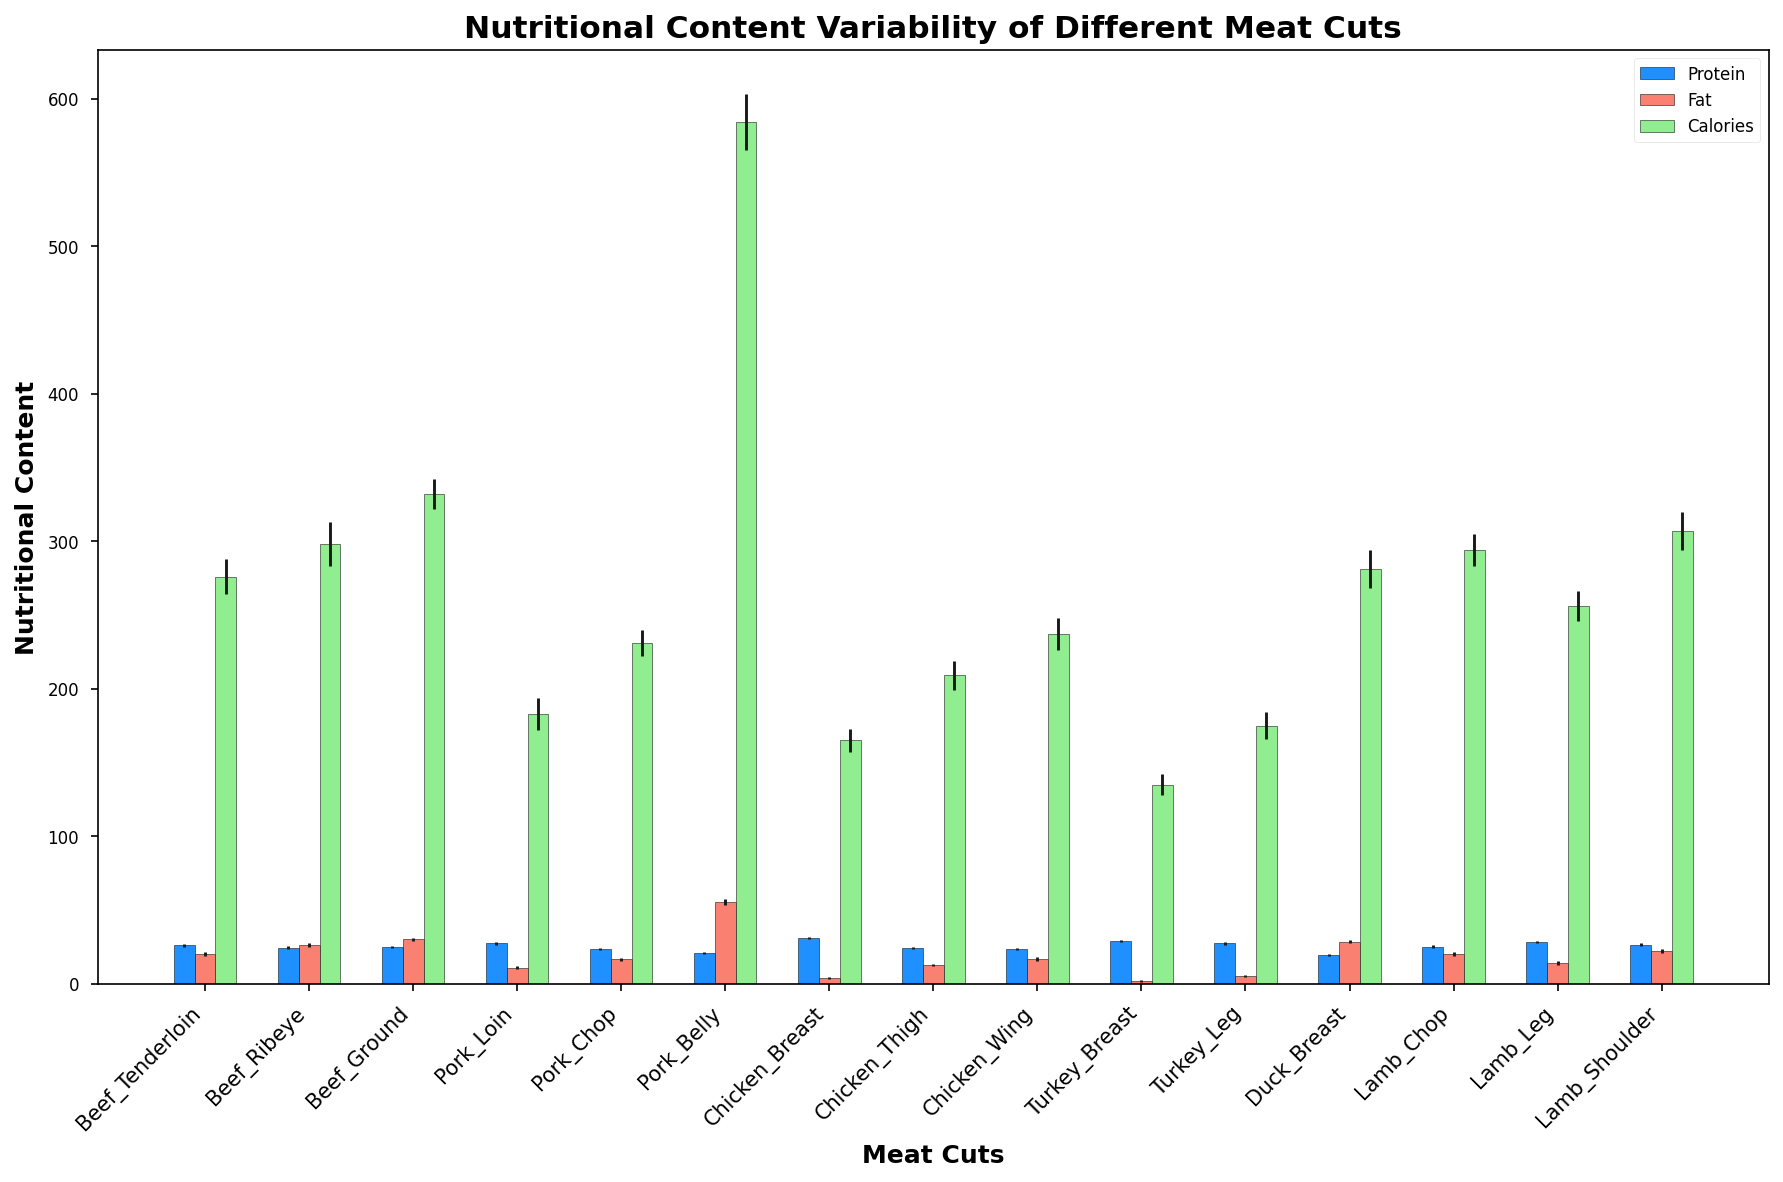Which meat cut has the highest average protein content? Look for the bar with the highest height in the protein section (blue bars). Chicken Breast has the highest protein mean value.
Answer: Chicken Breast Which meat cut has the lowest average fat content? Look for the bar with the lowest height in the fat section (salmon bars). Turkey Breast has the lowest fat mean value.
Answer: Turkey Breast Compare the caloric content of Beef Ribeye and Duck Breast. Which one is higher? Compare the heights of the green bars for Beef Ribeye and Duck Breast. Beef Ribeye's bar is lower than Duck Breast.
Answer: Duck Breast What is the difference in fat content between Pork Belly and Chicken Breast? Look at the heights of the salmon bars for Pork Belly and Chicken Breast. The difference in their heights is 55.2 - 3.6.
Answer: 51.6 Which meat cut shows the highest variability in calories? Look at the length of the error bars (black lines) on the green bars representing calories. Pork Belly's error bar is the longest.
Answer: Pork Belly What is the sum of the average protein and fat content for Lamb Shoulder? Add the average values of protein and fat for Lamb Shoulder: 26.4 + 22.3.
Answer: 48.7 How does the protein content of Pork Loin compare to that of Chicken Thigh? Compare the heights of the blue bars for Pork Loin and Chicken Thigh. Pork Loin's bar is higher.
Answer: Pork Loin Which meat cut has the most balanced protein and fat content, having similar values? Look for meat cuts where the heights of the blue and salmon bars are similar. Beef Tenderloin has close values of protein and fat.
Answer: Beef Tenderloin What is the average calorie content of the chicken meat cuts (Breast, Thigh, Wing)? Average the green bars for Chicken Breast, Thigh, and Wing: (165 + 209 + 237) / 3.
Answer: 203.7 What is the combined calorie mean for the leanest meat cuts (Chicken Breast, Turkey Breast)? Add the green bars for Chicken Breast and Turkey Breast: 165 + 135.
Answer: 300 